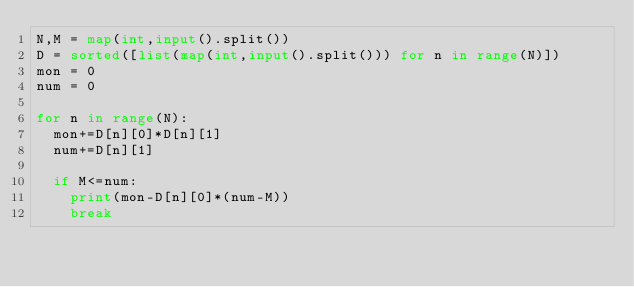Convert code to text. <code><loc_0><loc_0><loc_500><loc_500><_Python_>N,M = map(int,input().split())
D = sorted([list(map(int,input().split())) for n in range(N)])
mon = 0
num = 0

for n in range(N):
  mon+=D[n][0]*D[n][1]
  num+=D[n][1]
  
  if M<=num:
    print(mon-D[n][0]*(num-M))
    break</code> 